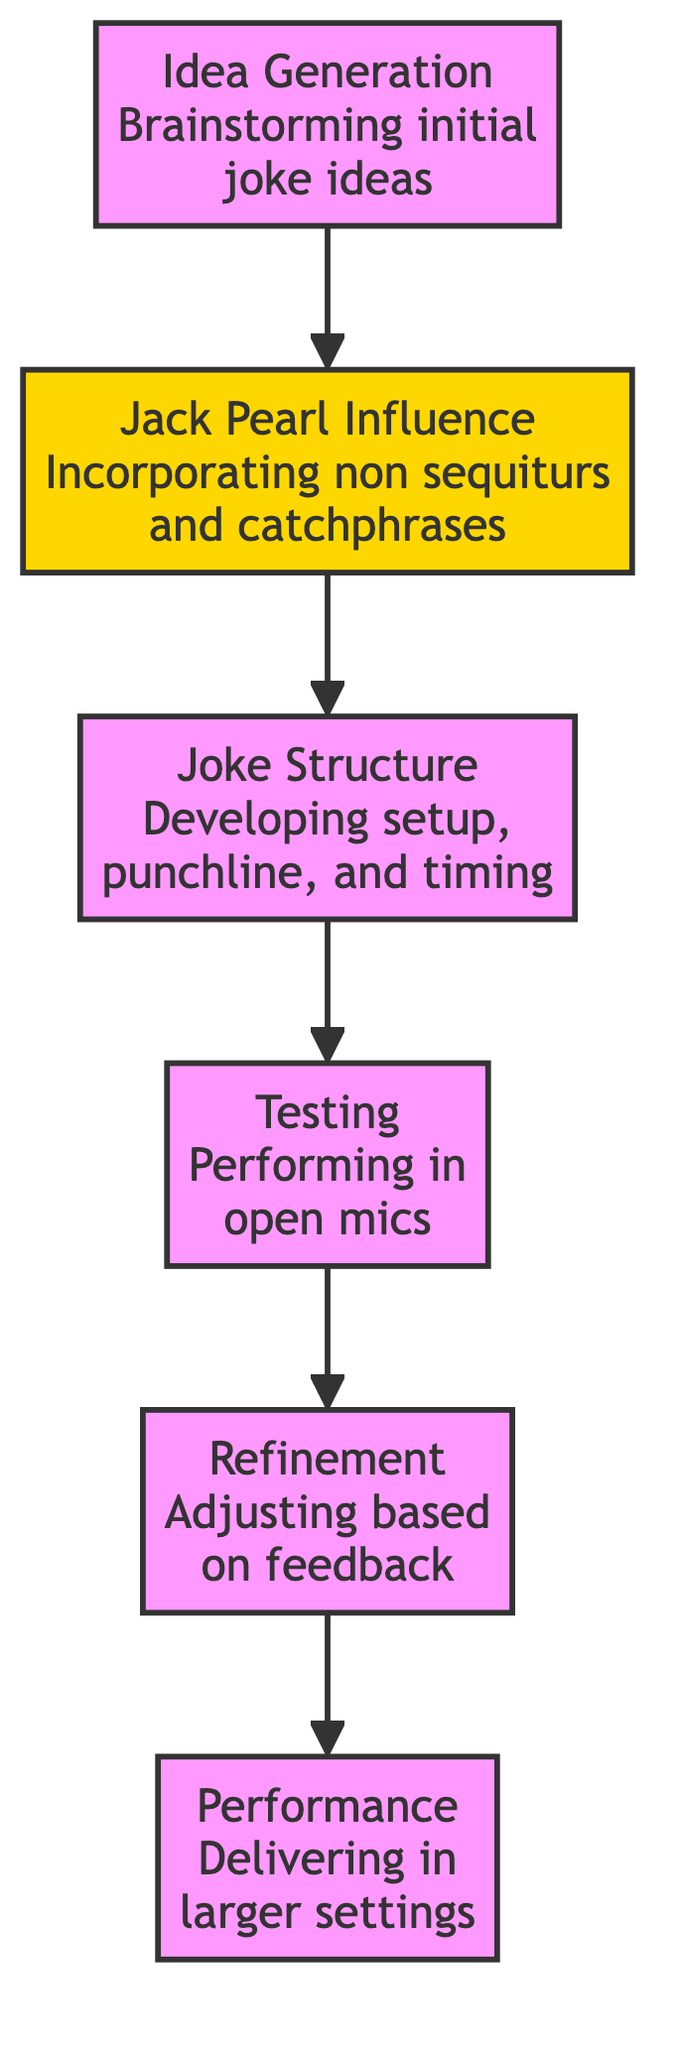What is the first step in the joke development process? The diagram indicates that the first step is "Idea Generation," which is the starting node of the directed graph.
Answer: Idea Generation How many nodes are present in the diagram? By counting the distinct nodes illustrated in the diagram, there are a total of six nodes: Idea Generation, Jack Pearl Influence, Joke Structure, Testing, Refinement, and Performance.
Answer: 6 What leads to the "Testing" phase? The phase that leads to "Testing" is "Joke Structure," which shows a directional connection to it in the diagram.
Answer: Joke Structure Which node includes Jack Pearl's influence? The node that includes Jack Pearl's influence is labeled "Jack Pearl Influence," and it directly follows "Idea Generation" in the process.
Answer: Jack Pearl Influence What is the final stage of the process? According to the diagram, the final stage of the process is "Performance," which is the last node with no outgoing edges.
Answer: Performance What is the main focus during the "Idea Generation" phase? The main focus during the "Idea Generation" phase is on brainstorming initial joke ideas with a focus on absurdity and surprise.
Answer: Absurdity and surprise How does feedback play a role in the development process? Feedback is critical during the "Refinement" phase, where adjustments are made based on audience reactions gathered during "Testing."
Answer: Refinement What type of humor does Jack Pearl's influence emphasize? Jack Pearl's influence emphasizes non sequiturs and catchy catchphrases, highlighting a unique comedic style.
Answer: Non sequiturs and catchphrases Which node serves as a bridge between "Jack Pearl Influence" and "Joke Structure"? The bridge between "Jack Pearl Influence" and "Joke Structure" is represented by the directed flow from "Jack Pearl Influence" to "Joke Structure."
Answer: Jack Pearl Influence 